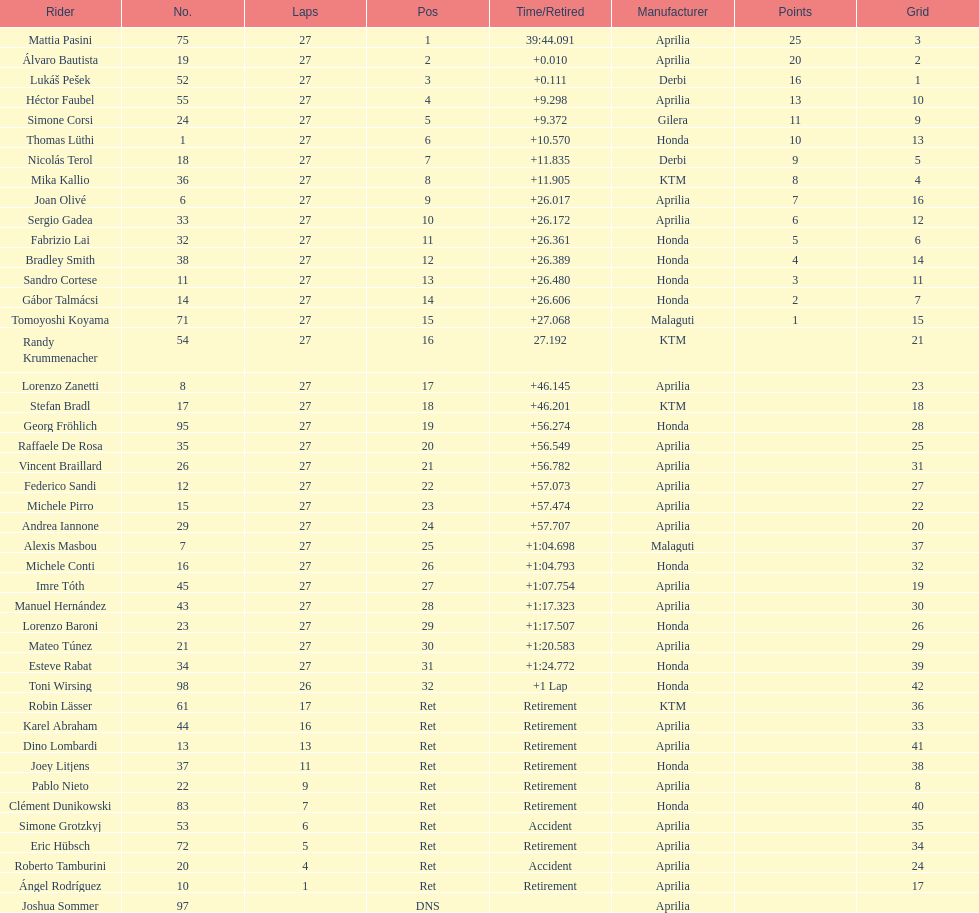What was the total number of positions in the 125cc classification? 43. 